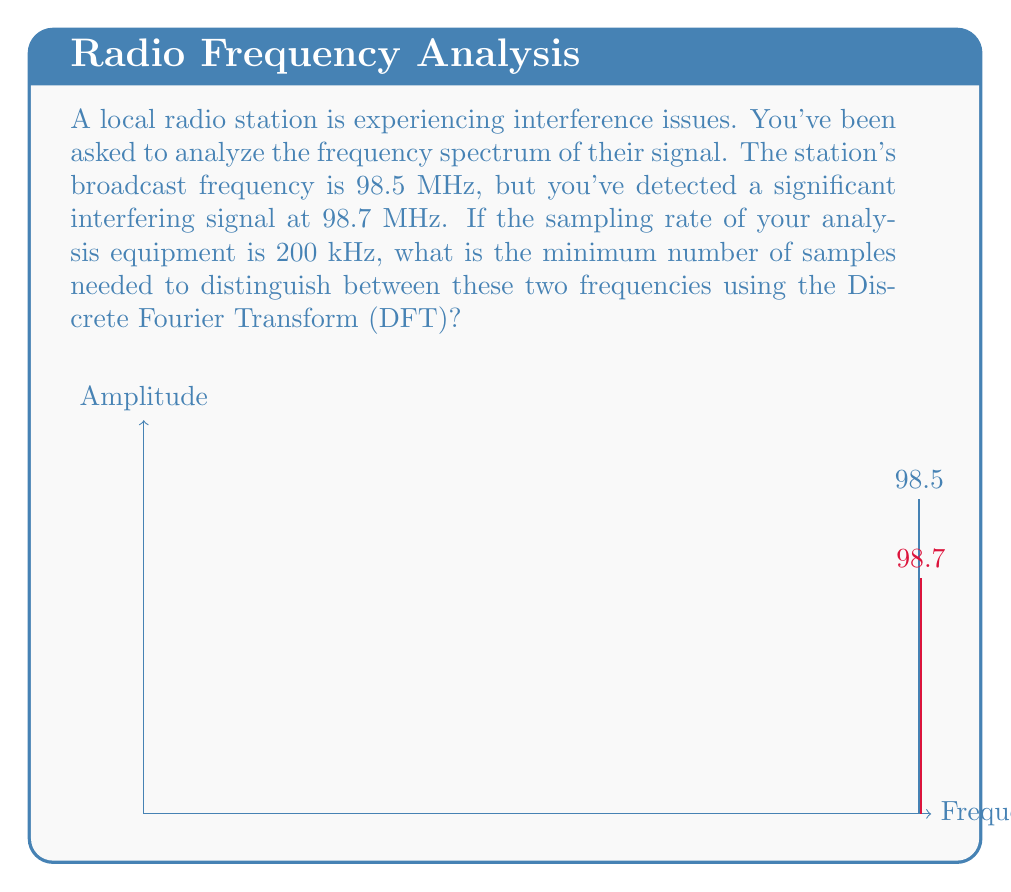What is the answer to this math problem? To solve this problem, we'll use the concept of frequency resolution in the DFT. Let's break it down step-by-step:

1) The frequency resolution of a DFT is given by:

   $$\Delta f = \frac{f_s}{N}$$

   where $f_s$ is the sampling frequency and $N$ is the number of samples.

2) We need to be able to distinguish between 98.5 MHz and 98.7 MHz. The difference is:

   $$98.7 \text{ MHz} - 98.5 \text{ MHz} = 0.2 \text{ MHz} = 200 \text{ kHz}$$

3) This means our frequency resolution needs to be at least 200 kHz. Let's set up the inequality:

   $$\frac{f_s}{N} \leq 200 \text{ kHz}$$

4) We're given that $f_s = 200 \text{ kHz}$. Substituting this:

   $$\frac{200 \text{ kHz}}{N} \leq 200 \text{ kHz}$$

5) Solving for $N$:

   $$N \geq \frac{200 \text{ kHz}}{200 \text{ kHz}} = 1$$

6) However, we need the minimum number of samples that can distinguish these frequencies. The next integer after 1 is 2, which would give us a frequency resolution of 100 kHz, allowing us to distinguish the two frequencies.

Therefore, the minimum number of samples needed is 2.
Answer: 2 samples 